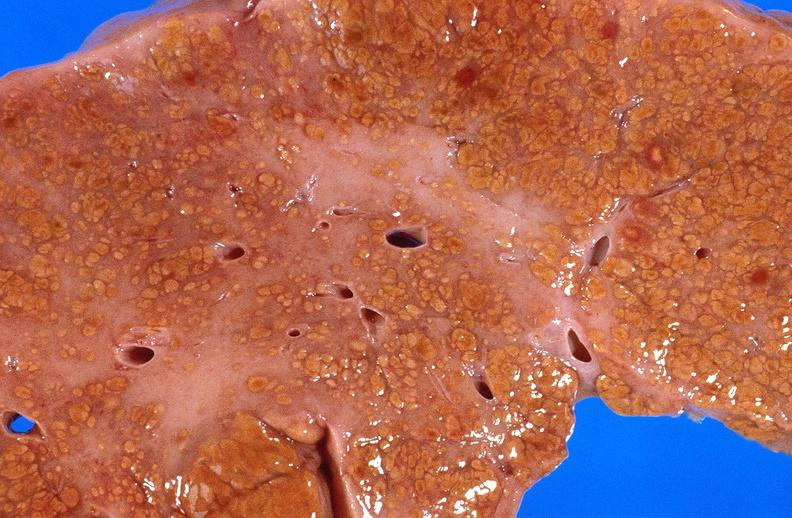s this myoma present?
Answer the question using a single word or phrase. No 